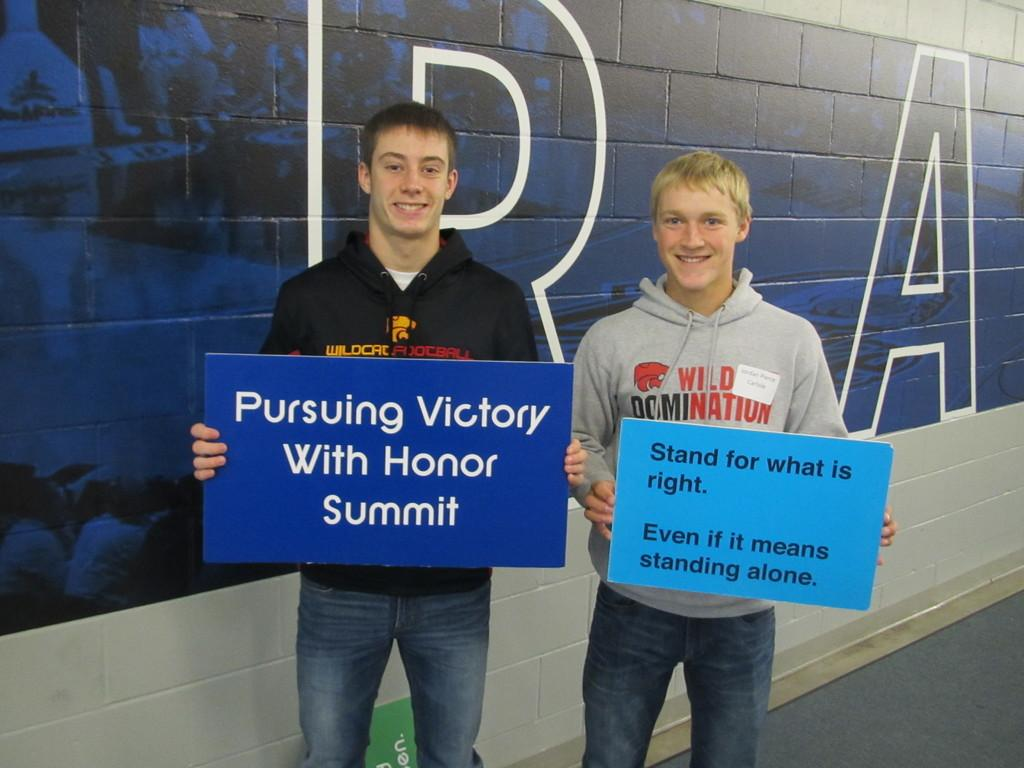How many people are in the image? There are two men in the image. What are the men doing in the image? The men are standing and holding boards with something written on them. What can be seen in the background of the image? There is a wall in the background of the image, and there is writing on the wall. What type of stitch is being used to sew the neck of the porter in the image? There is no porter or sewing activity present in the image. 